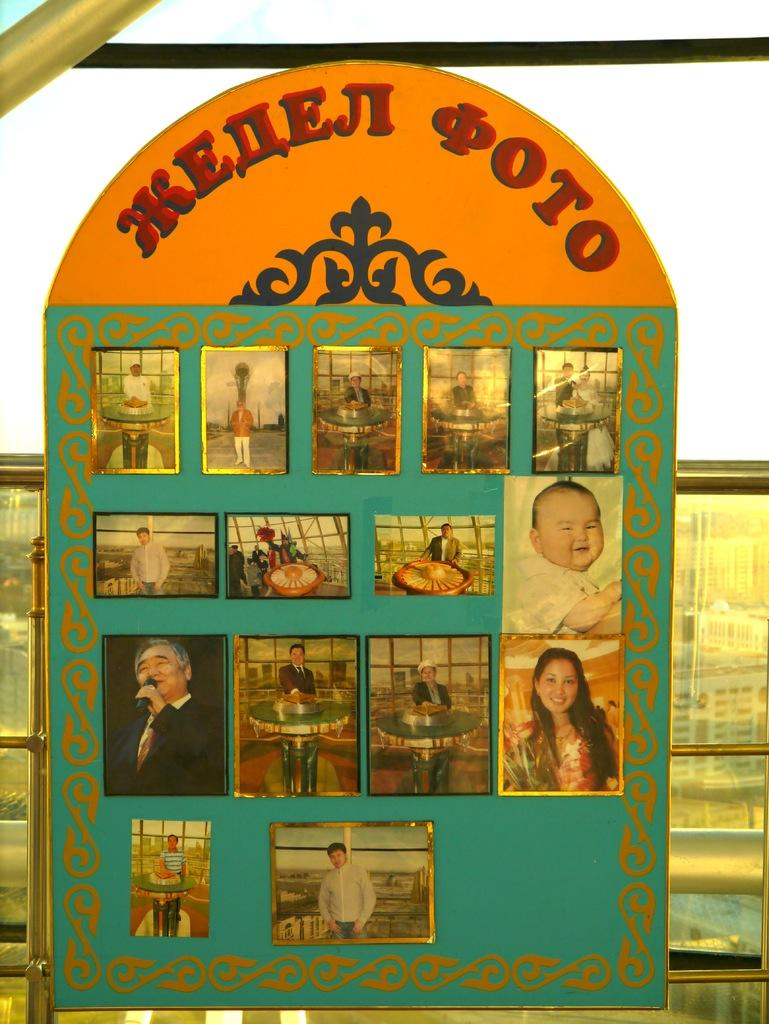What is the main object in the image? There is a board in the image. What is happening on the board? There are persons on the board. What type of soup is being served on the board in the image? There is no soup present in the image; it features a board with persons on it. What type of paste is visible on the board in the image? There is no paste present in the image; it features a board with persons on it. 